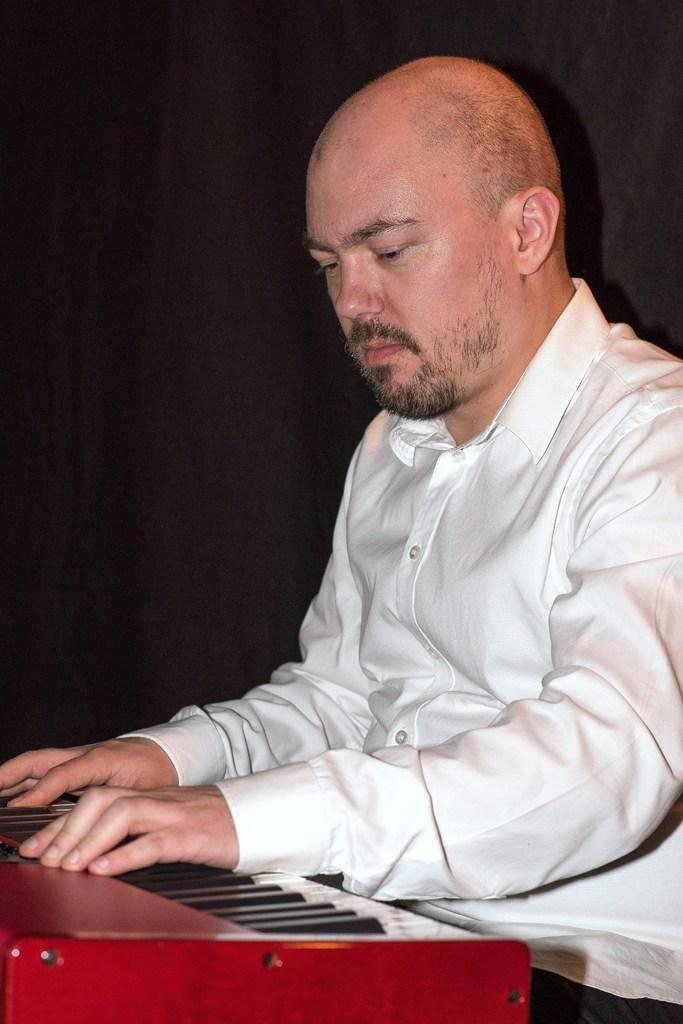What is the main subject of the image? There is a person playing a musical instrument in the image. Can you describe the background of the image? There is a black-colored curtain in the background of the image. What type of trousers is the person's daughter wearing in the image? There is no mention of a daughter in the image, and therefore no information about her trousers can be provided. 